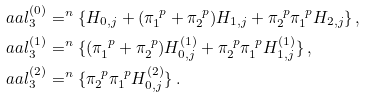<formula> <loc_0><loc_0><loc_500><loc_500>\ a a l _ { 3 } ^ { ( 0 ) } & = ^ { n } \{ H _ { 0 , j } + ( \pi _ { 1 } ^ { \ p } + \pi _ { 2 } ^ { \ p } ) H _ { 1 , j } + \pi _ { 2 } ^ { \ p } \pi _ { 1 } ^ { \ p } H _ { 2 , j } \} \, , \\ \ a a l _ { 3 } ^ { ( 1 ) } & = ^ { n } \{ ( \pi _ { 1 } ^ { \ p } + \pi _ { 2 } ^ { \ p } ) H _ { 0 , j } ^ { ( 1 ) } + \pi _ { 2 } ^ { \ p } \pi _ { 1 } ^ { \ p } H _ { 1 , j } ^ { ( 1 ) } \} \, , \\ \ a a l _ { 3 } ^ { ( 2 ) } & = ^ { n } \{ \pi _ { 2 } ^ { \ p } \pi _ { 1 } ^ { \ p } H _ { 0 , j } ^ { ( 2 ) } \} \, .</formula> 